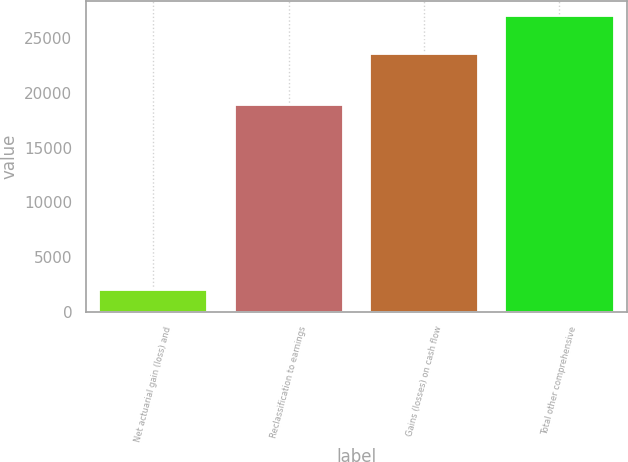Convert chart. <chart><loc_0><loc_0><loc_500><loc_500><bar_chart><fcel>Net actuarial gain (loss) and<fcel>Reclassification to earnings<fcel>Gains (losses) on cash flow<fcel>Total other comprehensive<nl><fcel>2002<fcel>18910<fcel>23520<fcel>27012<nl></chart> 